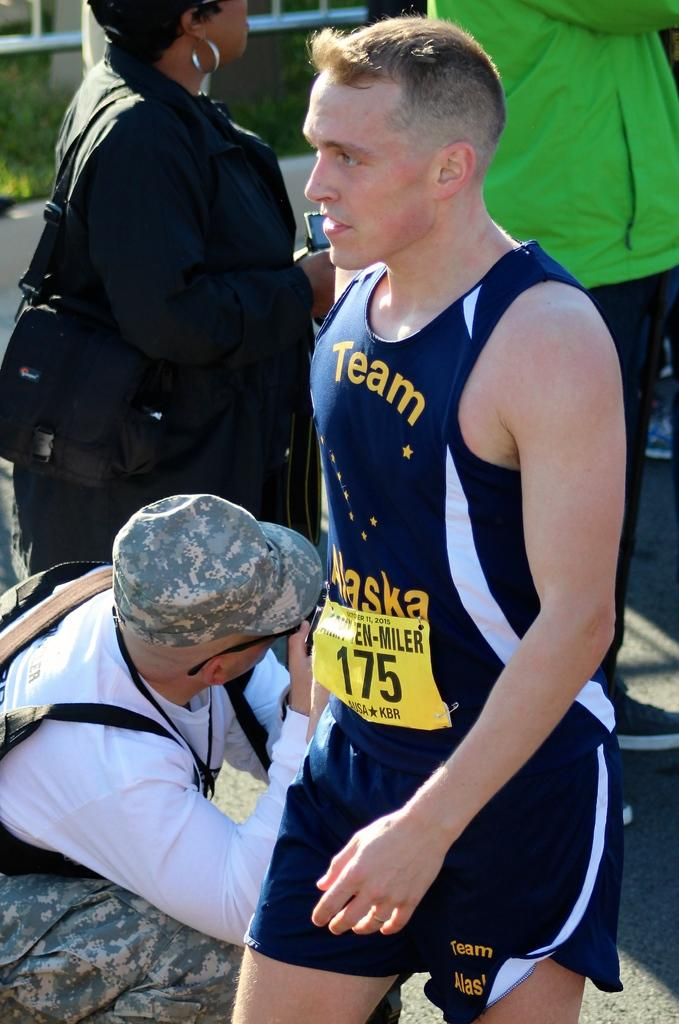<image>
Offer a succinct explanation of the picture presented. The athlete shown wears the number 175 number on their bib. 